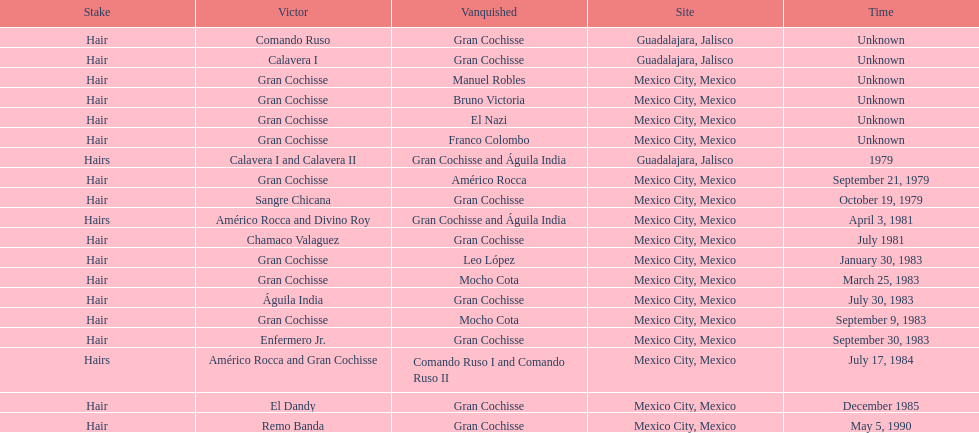When was gran chochisse first match that had a full date on record? September 21, 1979. 